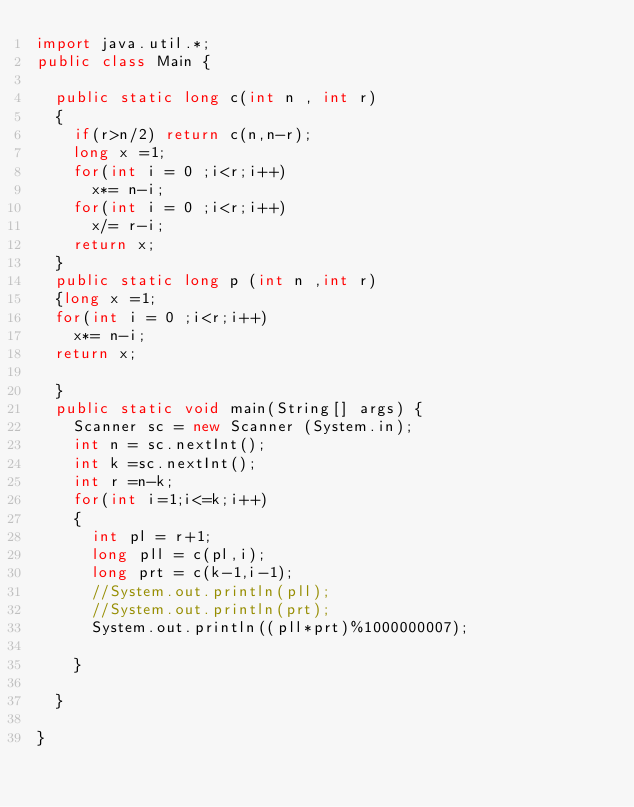Convert code to text. <code><loc_0><loc_0><loc_500><loc_500><_Java_>import java.util.*;
public class Main {
	
	public static long c(int n , int r)
	{
		if(r>n/2) return c(n,n-r);
		long x =1;
		for(int i = 0 ;i<r;i++)
			x*= n-i;
		for(int i = 0 ;i<r;i++)
			x/= r-i;
		return x;
	}
	public static long p (int n ,int r)
	{long x =1;
	for(int i = 0 ;i<r;i++)
		x*= n-i;
	return x;
		
	}
	public static void main(String[] args) {
		Scanner sc = new Scanner (System.in);
		int n = sc.nextInt();
		int k =sc.nextInt();
		int r =n-k;
		for(int i=1;i<=k;i++)
		{		
			int pl = r+1;
			long pll = c(pl,i);	
			long prt = c(k-1,i-1);
			//System.out.println(pll);
			//System.out.println(prt);
			System.out.println((pll*prt)%1000000007);			
			
		}

	}

}
</code> 